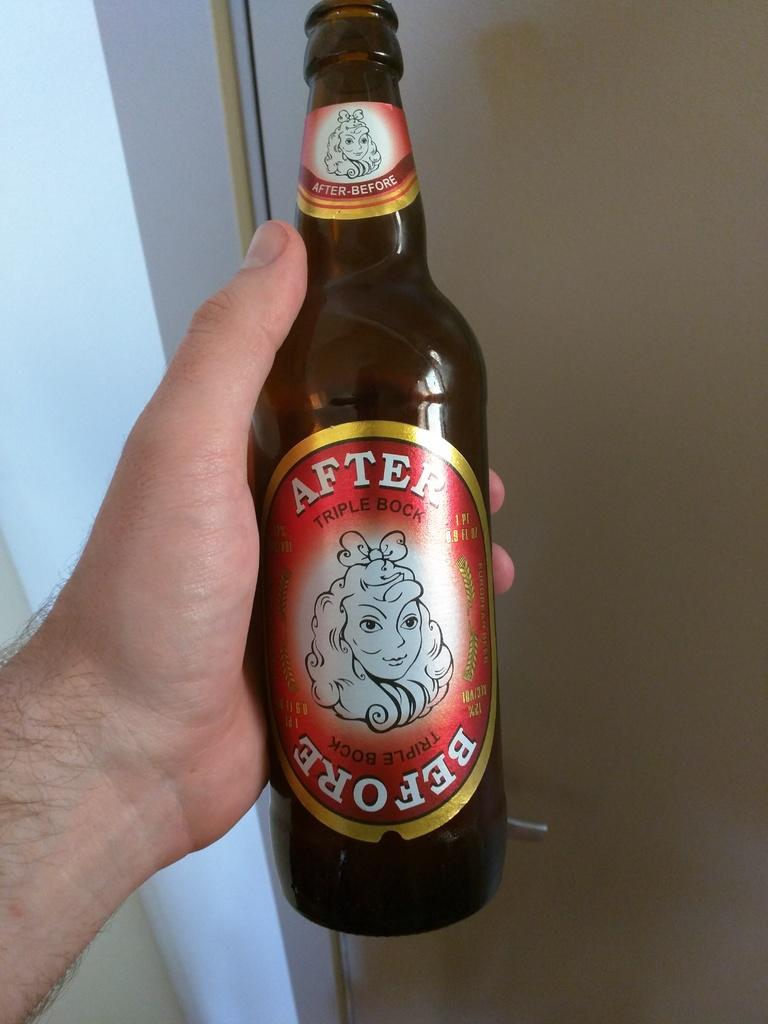<image>
Share a concise interpretation of the image provided. a bottle of beer with the label reading after and before 